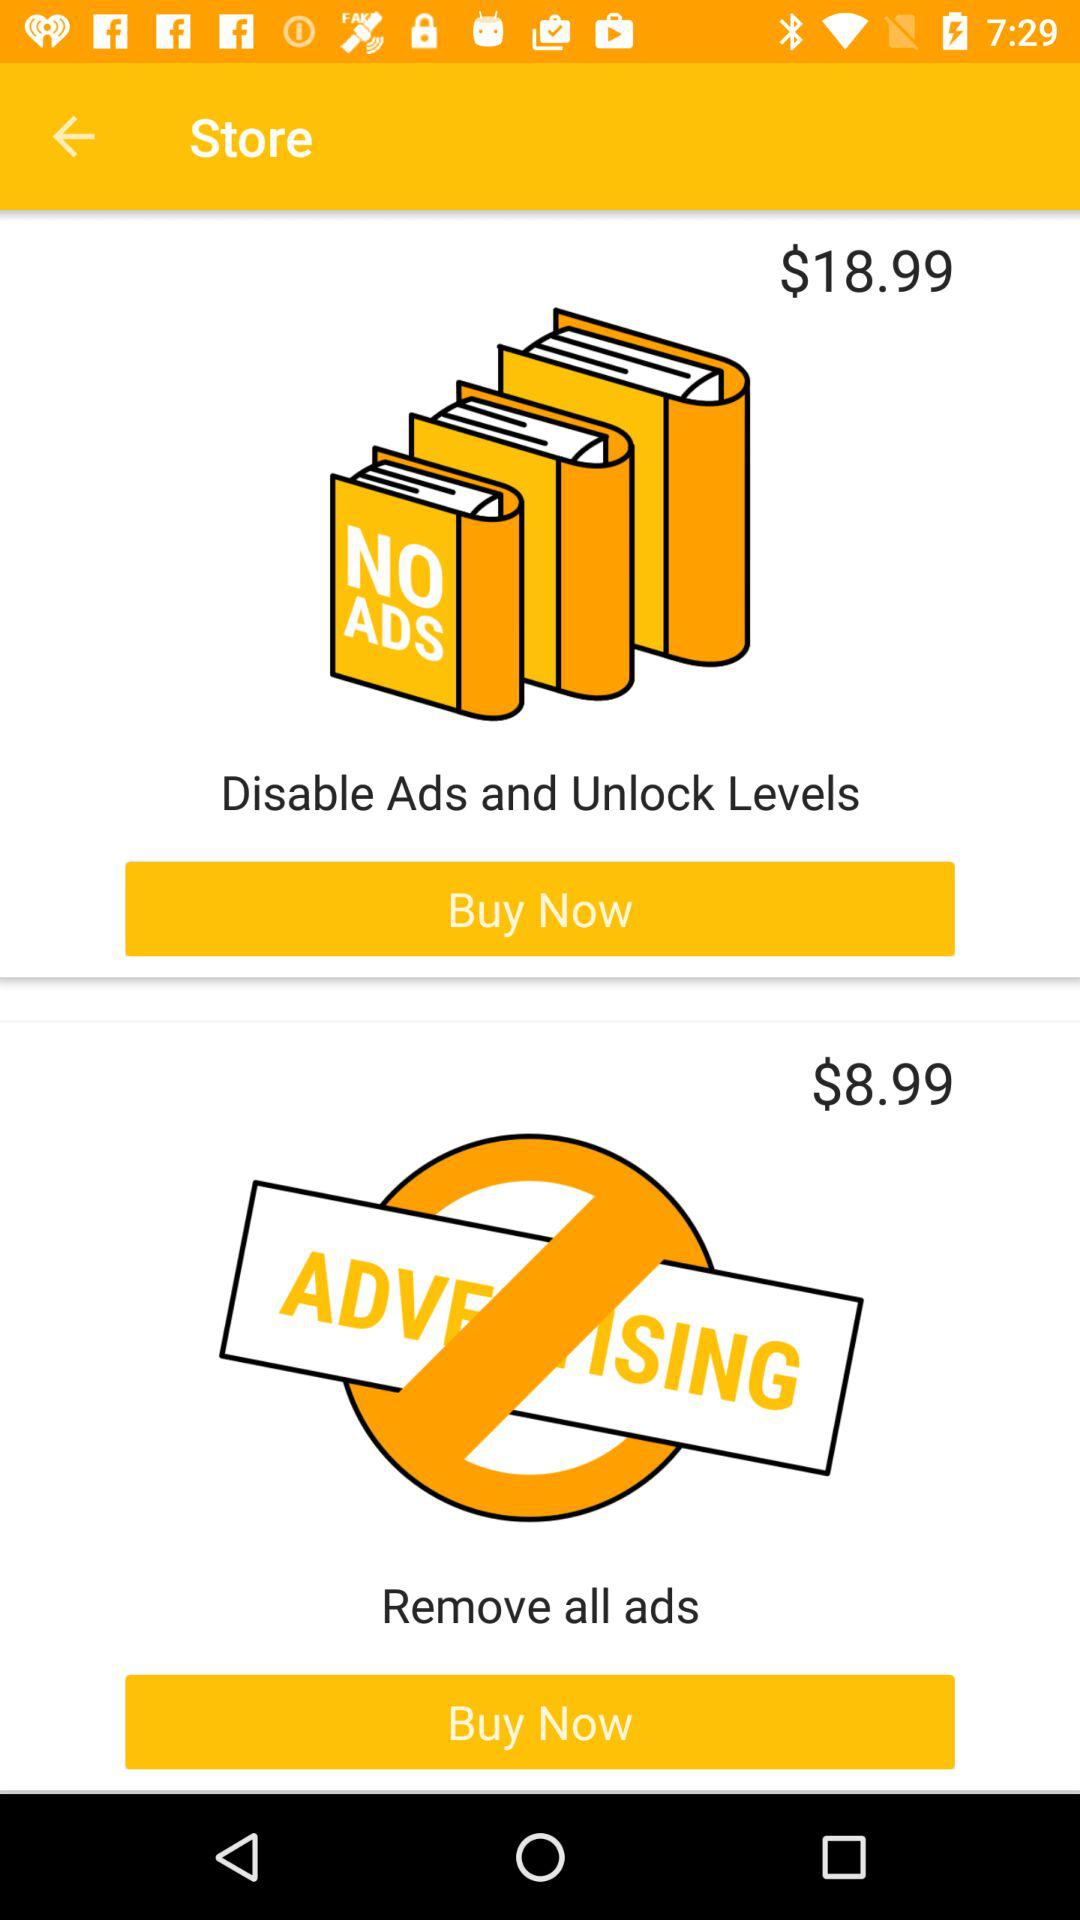Which item costs more, the $18.99 item or the $8.99 item?
Answer the question using a single word or phrase. $18.99 